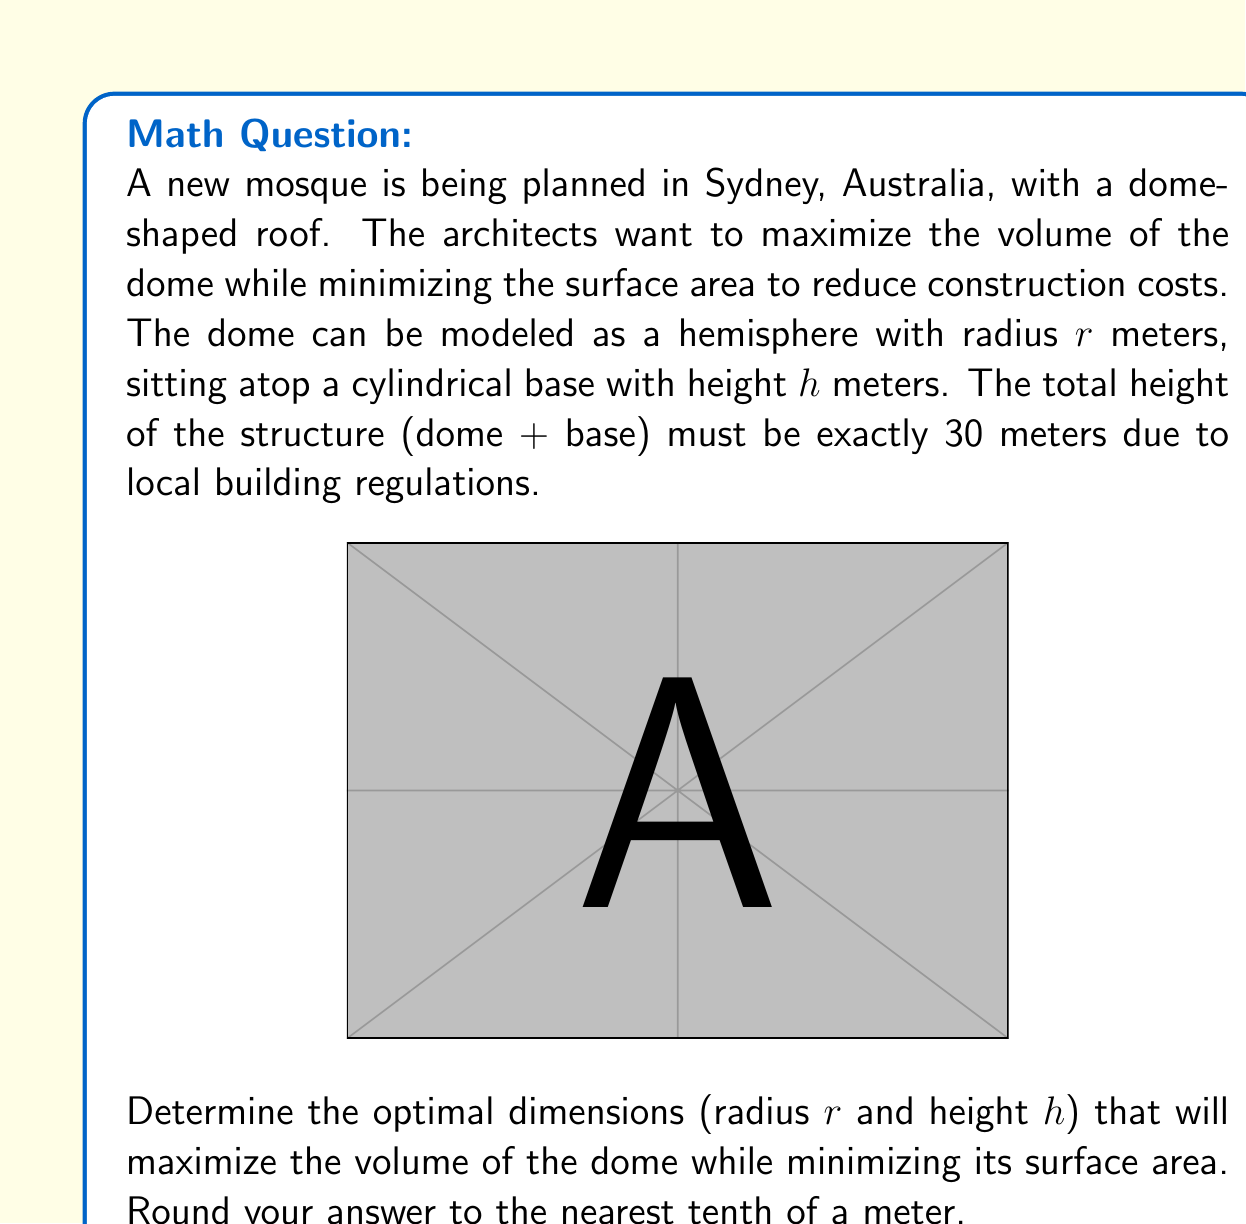Can you solve this math problem? Let's approach this step-by-step:

1) First, we need to express $h$ in terms of $r$:
   $$h + r = 30$$
   $$h = 30 - r$$

2) The volume $V$ of the structure is the sum of the cylinder volume and the hemisphere volume:
   $$V = \pi r^2 h + \frac{2}{3}\pi r^3$$
   $$V = \pi r^2 (30-r) + \frac{2}{3}\pi r^3$$
   $$V = 30\pi r^2 - \pi r^3 + \frac{2}{3}\pi r^3$$
   $$V = 30\pi r^2 - \frac{1}{3}\pi r^3$$

3) The surface area $S$ is the sum of the cylinder's lateral area and the hemisphere's surface area:
   $$S = 2\pi r h + 2\pi r^2$$
   $$S = 2\pi r(30-r) + 2\pi r^2$$
   $$S = 60\pi r - 2\pi r^2 + 2\pi r^2$$
   $$S = 60\pi r$$

4) To optimize, we need to maximize $V$ while minimizing $S$. We can do this by maximizing the ratio $\frac{V}{S}$:

   $$\frac{V}{S} = \frac{30\pi r^2 - \frac{1}{3}\pi r^3}{60\pi r} = \frac{r}{2} - \frac{r^2}{180}$$

5) To find the maximum of this function, we differentiate and set to zero:

   $$\frac{d}{dr}\left(\frac{r}{2} - \frac{r^2}{180}\right) = \frac{1}{2} - \frac{r}{90} = 0$$

6) Solving this equation:
   $$\frac{1}{2} - \frac{r}{90} = 0$$
   $$\frac{r}{90} = \frac{1}{2}$$
   $$r = 45$$

7) However, remember that $r$ cannot be greater than 30 (the total height). The maximum of our ratio function within the valid range will occur at $r = 15$ (half of the total height).

8) Therefore, the optimal dimensions are:
   $$r = 15\text{ m}$$
   $$h = 30 - 15 = 15\text{ m}$$
Answer: $r = 15.0$ m, $h = 15.0$ m 